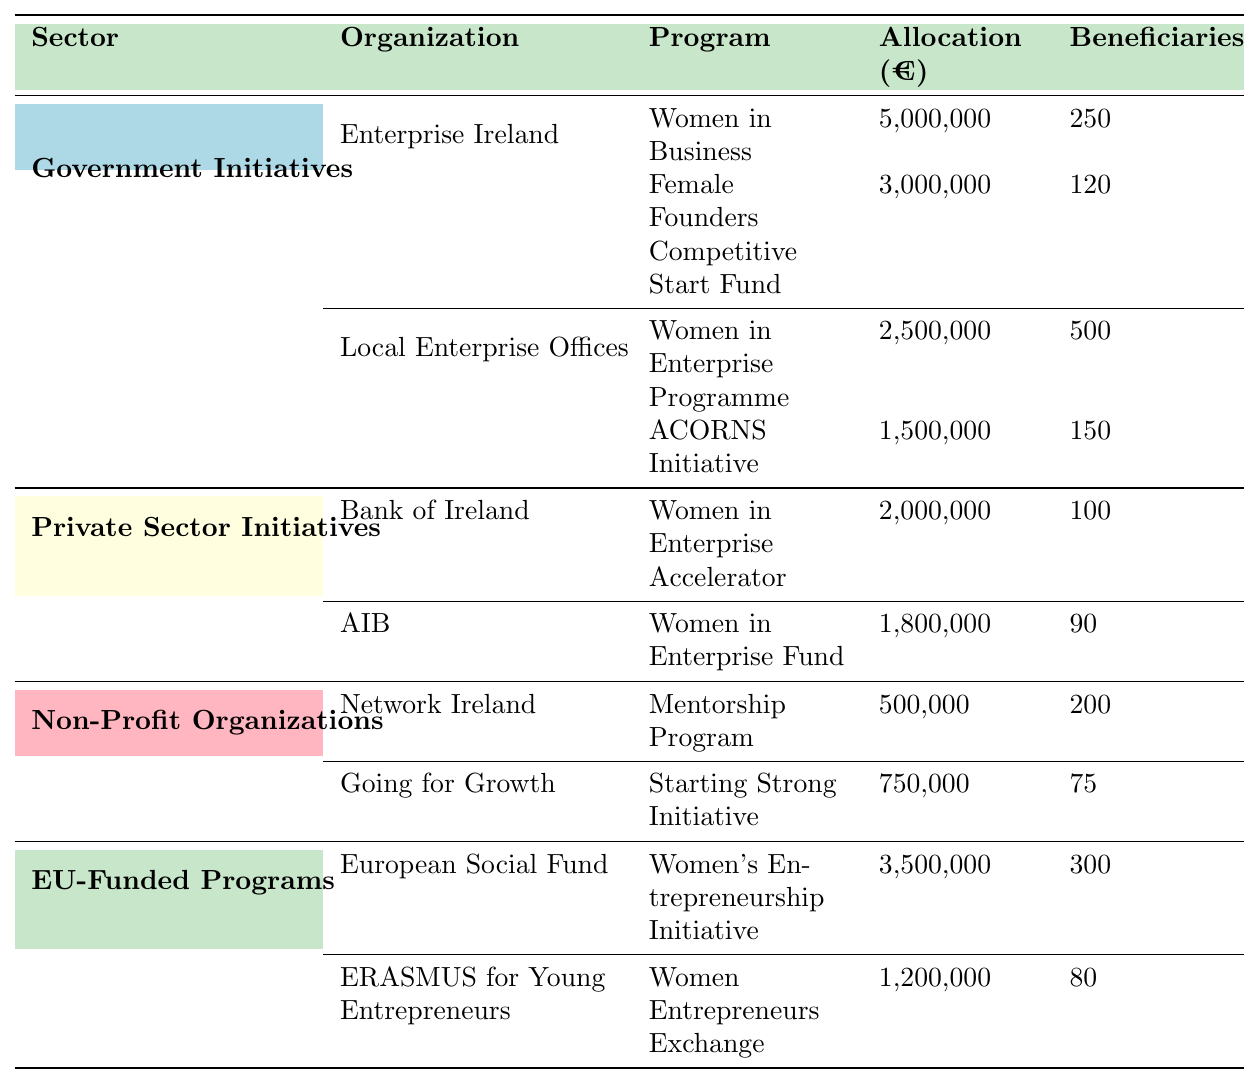What is the total funding allocation for Government Initiatives? To find the total funding allocation for Government Initiatives, I will sum the allocations for all programs under this category: 5,000,000 (Women in Business) + 3,000,000 (Female Founders Competitive Start Fund) + 2,500,000 (Women in Enterprise Programme) + 1,500,000 (ACORNS Initiative) = 12,000,000.
Answer: 12,000,000 How many beneficiaries are supported by the Private Sector Initiatives? To determine the total beneficiaries for Private Sector Initiatives, I add the beneficiaries from both programs: 100 (Women in Enterprise Accelerator) + 90 (Women in Enterprise Fund) = 190.
Answer: 190 Which organization received the highest allocation among the Government Initiatives? By comparing the allocations in Government Initiatives, Enterprise Ireland received 5,000,000 (Women in Business), which is higher than the other allocations: 3,000,000 (Female Founders Competitive Start Fund), 2,500,000 (Women in Enterprise Programme), and 1,500,000 (ACORNS Initiative).
Answer: Enterprise Ireland Is the allocation for the "Women Entrepreneurs Exchange" program higher than 1 million euros? The allocation for the "Women Entrepreneurs Exchange" program is 1,200,000 euros, which is indeed higher than 1 million euros.
Answer: Yes What is the average allocation per beneficiary for Non-Profit Organizations? I will calculate the average allocation per beneficiary by first summing the allocations: 500,000 (Mentorship Program) + 750,000 (Starting Strong Initiative) = 1,250,000, and then summing the beneficiaries: 200 + 75 = 275. Finally, I divide total allocation by total beneficiaries: 1,250,000 / 275 ≈ 4,545.45.
Answer: 4,545.45 Which sector has the most beneficiaries in total? To find out which sector has the most beneficiaries, I will sum the beneficiaries from all organizations in each sector. Government Initiatives: 250 + 120 + 500 + 150 = 1,020. Private Sector Initiatives: 100 + 90 = 190. Non-Profit Organizations: 200 + 75 = 275. EU-Funded Programs: 300 + 80 = 380. The highest total is in Government Initiatives with 1,020 beneficiaries.
Answer: Government Initiatives What percentage of the total funding for Non-Profit Organizations is allocated to the "Mentorship Program"? The total funding for Non-Profit Organizations is 500,000 + 750,000 = 1,250,000. The allocation for the "Mentorship Program" is 500,000. To find the percentage, I calculate (500,000 / 1,250,000) * 100 = 40%.
Answer: 40% Which program in the EU-Funded Programs has the highest number of beneficiaries? By examining the beneficiaries in EU-Funded Programs, I find that the "Women's Entrepreneurship Initiative" has 300 beneficiaries, while the "Women Entrepreneurs Exchange" has 80. Thus, the "Women's Entrepreneurship Initiative" has the highest number of beneficiaries.
Answer: Women's Entrepreneurship Initiative What is the difference in allocations between the highest and lowest funded programs in the table? The highest funded program is "Women in Business" with 5,000,000 euros, and the lowest funded program is "Going for Growth" with 750,000 euros. The difference is 5,000,000 - 750,000 = 4,250,000 euros.
Answer: 4,250,000 If the funding for the "ACORNS Initiative" were to increase by 10%, what would its new allocation be? The current allocation for the "ACORNS Initiative" is 1,500,000 euros. To calculate a 10% increase, I find 10% of 1,500,000, which is 150,000. Adding this to the original allocation gives: 1,500,000 + 150,000 = 1,650,000 euros.
Answer: 1,650,000 